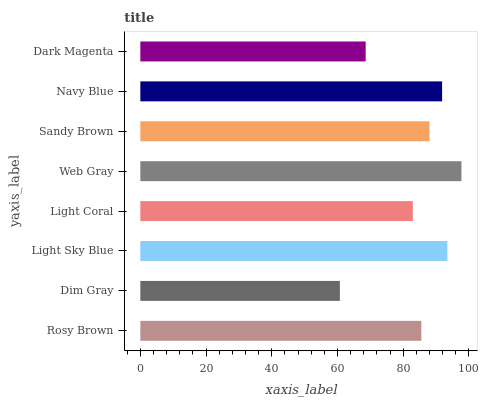Is Dim Gray the minimum?
Answer yes or no. Yes. Is Web Gray the maximum?
Answer yes or no. Yes. Is Light Sky Blue the minimum?
Answer yes or no. No. Is Light Sky Blue the maximum?
Answer yes or no. No. Is Light Sky Blue greater than Dim Gray?
Answer yes or no. Yes. Is Dim Gray less than Light Sky Blue?
Answer yes or no. Yes. Is Dim Gray greater than Light Sky Blue?
Answer yes or no. No. Is Light Sky Blue less than Dim Gray?
Answer yes or no. No. Is Sandy Brown the high median?
Answer yes or no. Yes. Is Rosy Brown the low median?
Answer yes or no. Yes. Is Rosy Brown the high median?
Answer yes or no. No. Is Web Gray the low median?
Answer yes or no. No. 